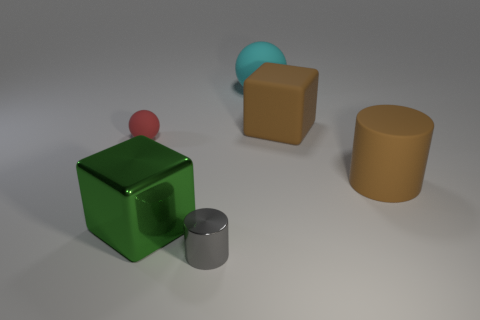Add 2 small gray things. How many objects exist? 8 Subtract all cubes. How many objects are left? 4 Subtract all big gray metal things. Subtract all big cyan rubber objects. How many objects are left? 5 Add 6 rubber objects. How many rubber objects are left? 10 Add 1 metallic blocks. How many metallic blocks exist? 2 Subtract 0 gray cubes. How many objects are left? 6 